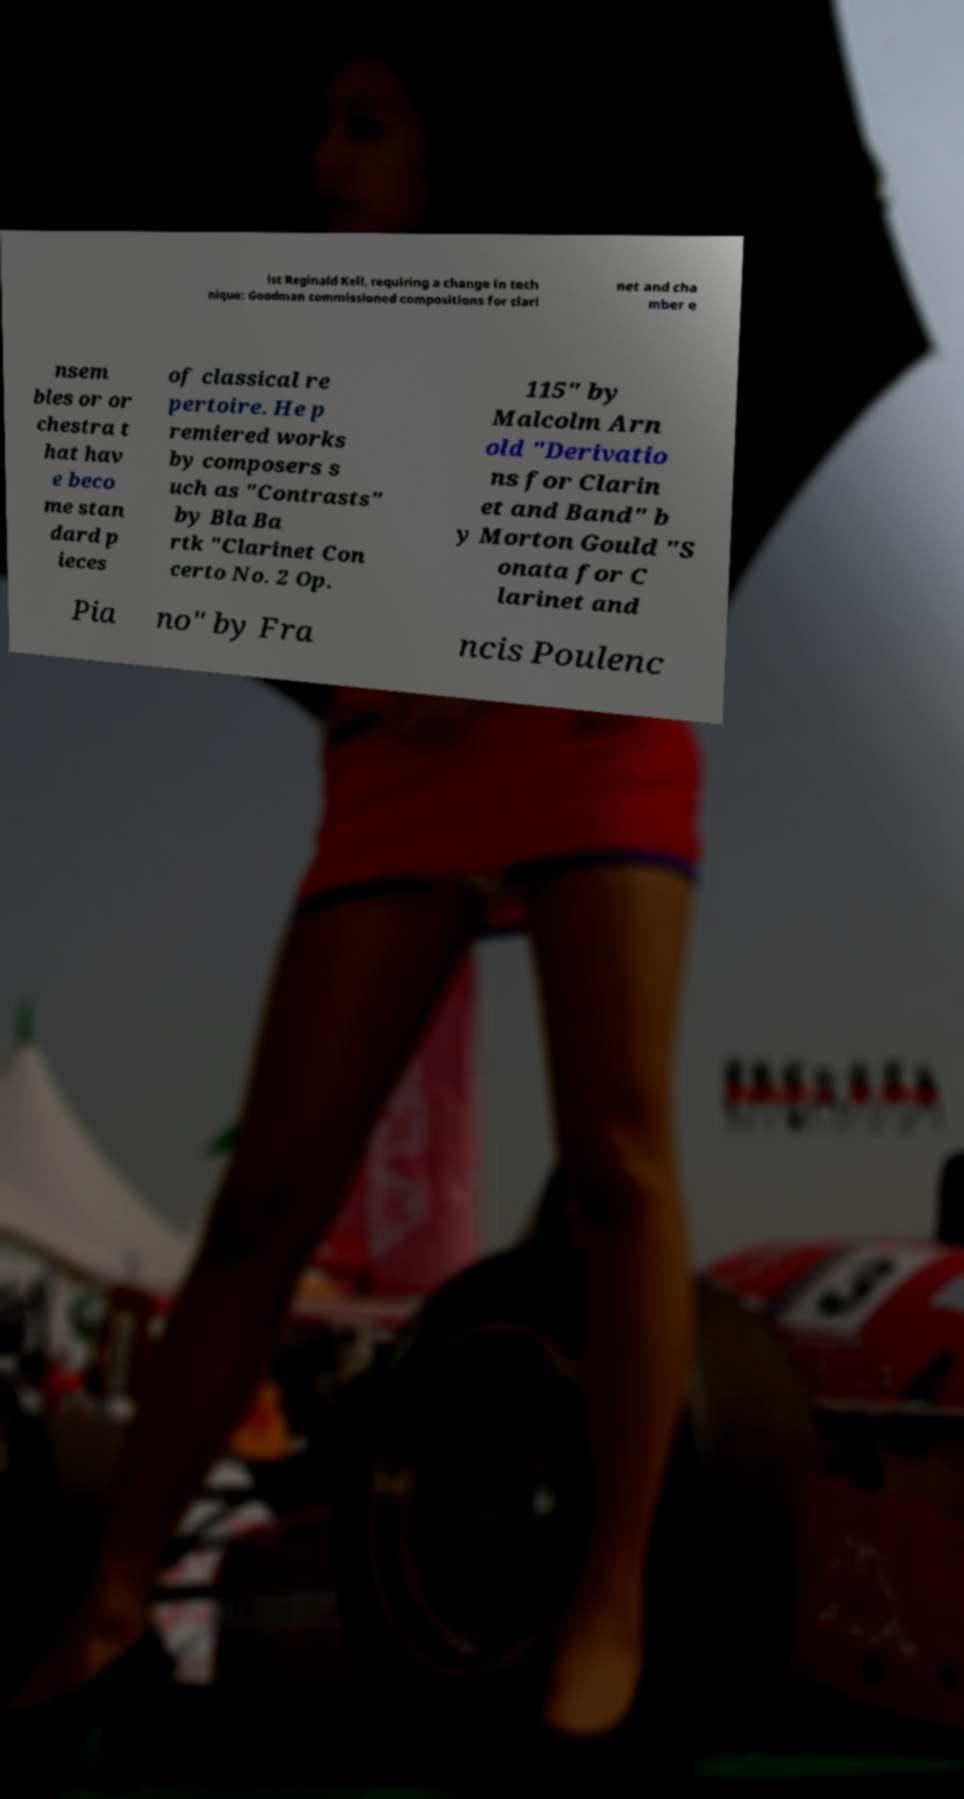There's text embedded in this image that I need extracted. Can you transcribe it verbatim? ist Reginald Kell, requiring a change in tech nique: Goodman commissioned compositions for clari net and cha mber e nsem bles or or chestra t hat hav e beco me stan dard p ieces of classical re pertoire. He p remiered works by composers s uch as "Contrasts" by Bla Ba rtk "Clarinet Con certo No. 2 Op. 115" by Malcolm Arn old "Derivatio ns for Clarin et and Band" b y Morton Gould "S onata for C larinet and Pia no" by Fra ncis Poulenc 